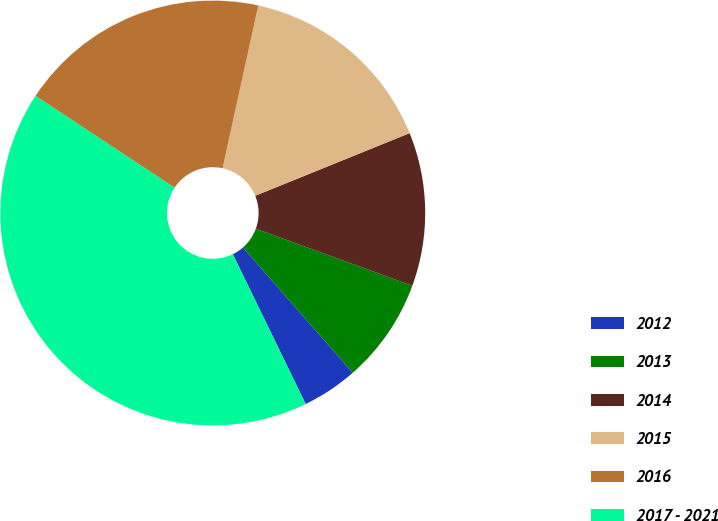Convert chart. <chart><loc_0><loc_0><loc_500><loc_500><pie_chart><fcel>2012<fcel>2013<fcel>2014<fcel>2015<fcel>2016<fcel>2017 - 2021<nl><fcel>4.25%<fcel>7.98%<fcel>11.7%<fcel>15.43%<fcel>19.15%<fcel>41.49%<nl></chart> 